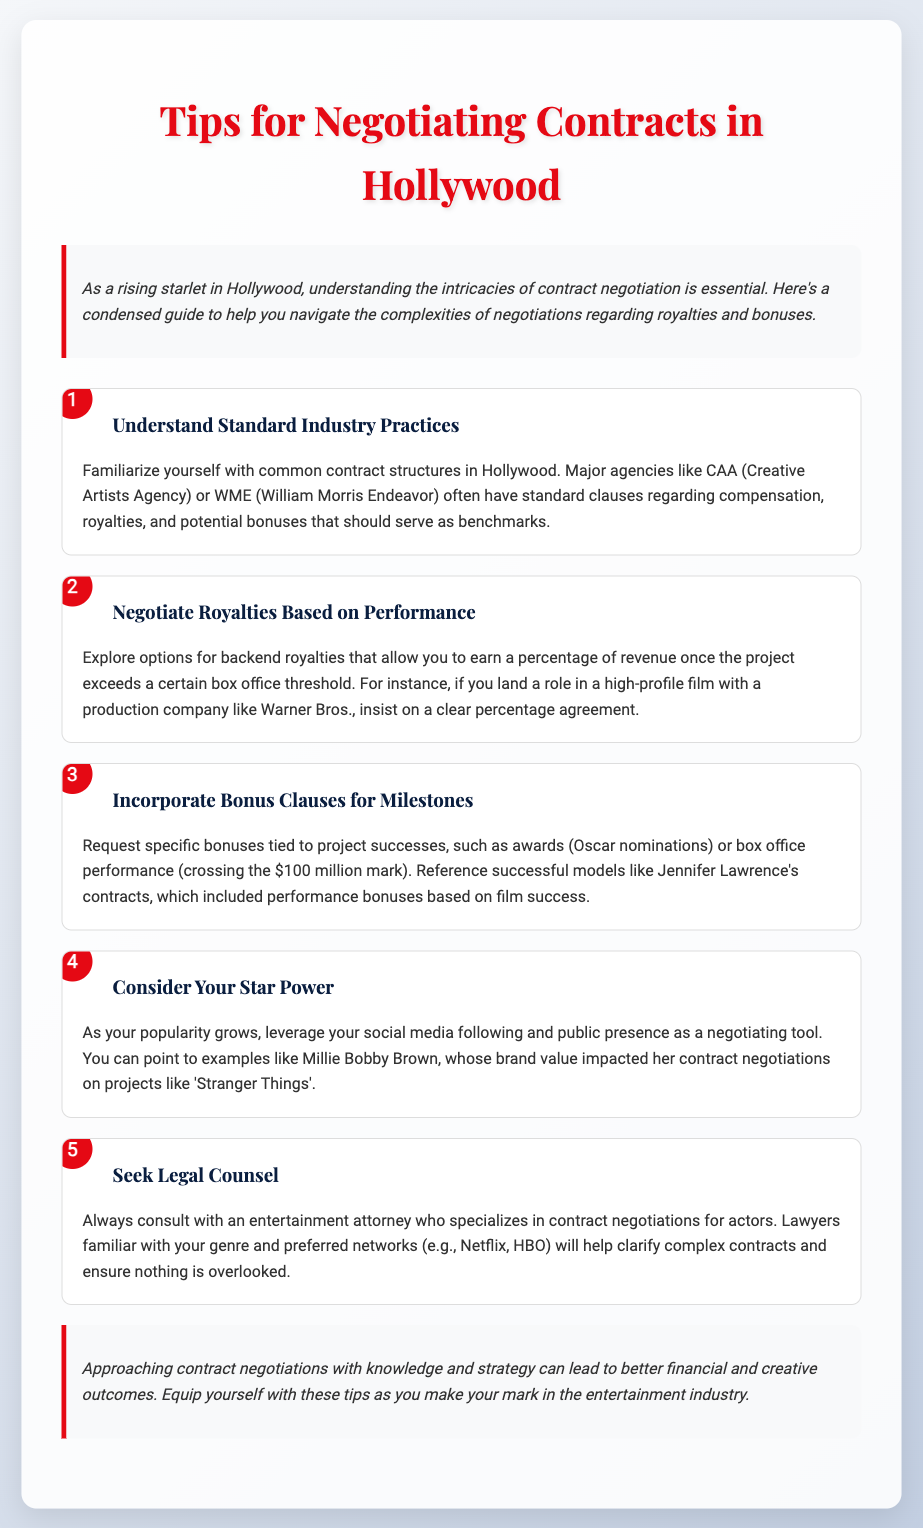What is a key agency mentioned for standard practices? CAA (Creative Artists Agency) is highlighted as a major agency for understanding common contract structures in Hollywood.
Answer: CAA What type of royalties should you negotiate based on performance? The document suggests exploring backend royalties that depend on project performance exceeding certain box office thresholds.
Answer: Backend royalties What kind of bonuses can be requested tied to project successes? The note mentions specific bonuses tied to milestones like awards or box office performance as something to request during negotiations.
Answer: Performance bonuses Which actress's contracts are referenced for including performance bonuses? The guidance references Jennifer Lawrence's contracts as a successful example that included performance bonuses based on film success.
Answer: Jennifer Lawrence What should you do before finalizing a contract? The document emphasizes the importance of consulting with an entertainment attorney who specializes in contract negotiations for actors before finalizing any contract.
Answer: Seek legal counsel How does social media factor into negotiations according to the note? The note suggests leveraging social media following as a tool for negotiation, citing Millie Bobby Brown as an example of how brand value impacts contracts.
Answer: Social media following What is the overall purpose of the tips provided? The overarching objective of these tips is to equip rising starlets with the knowledge and strategies to navigate contract negotiations effectively in the entertainment industry.
Answer: Effective negotiation What color is primarily used in the document's title? The title features the color red, which is consistent throughout the document in areas such as headings and emphasis.
Answer: Red 